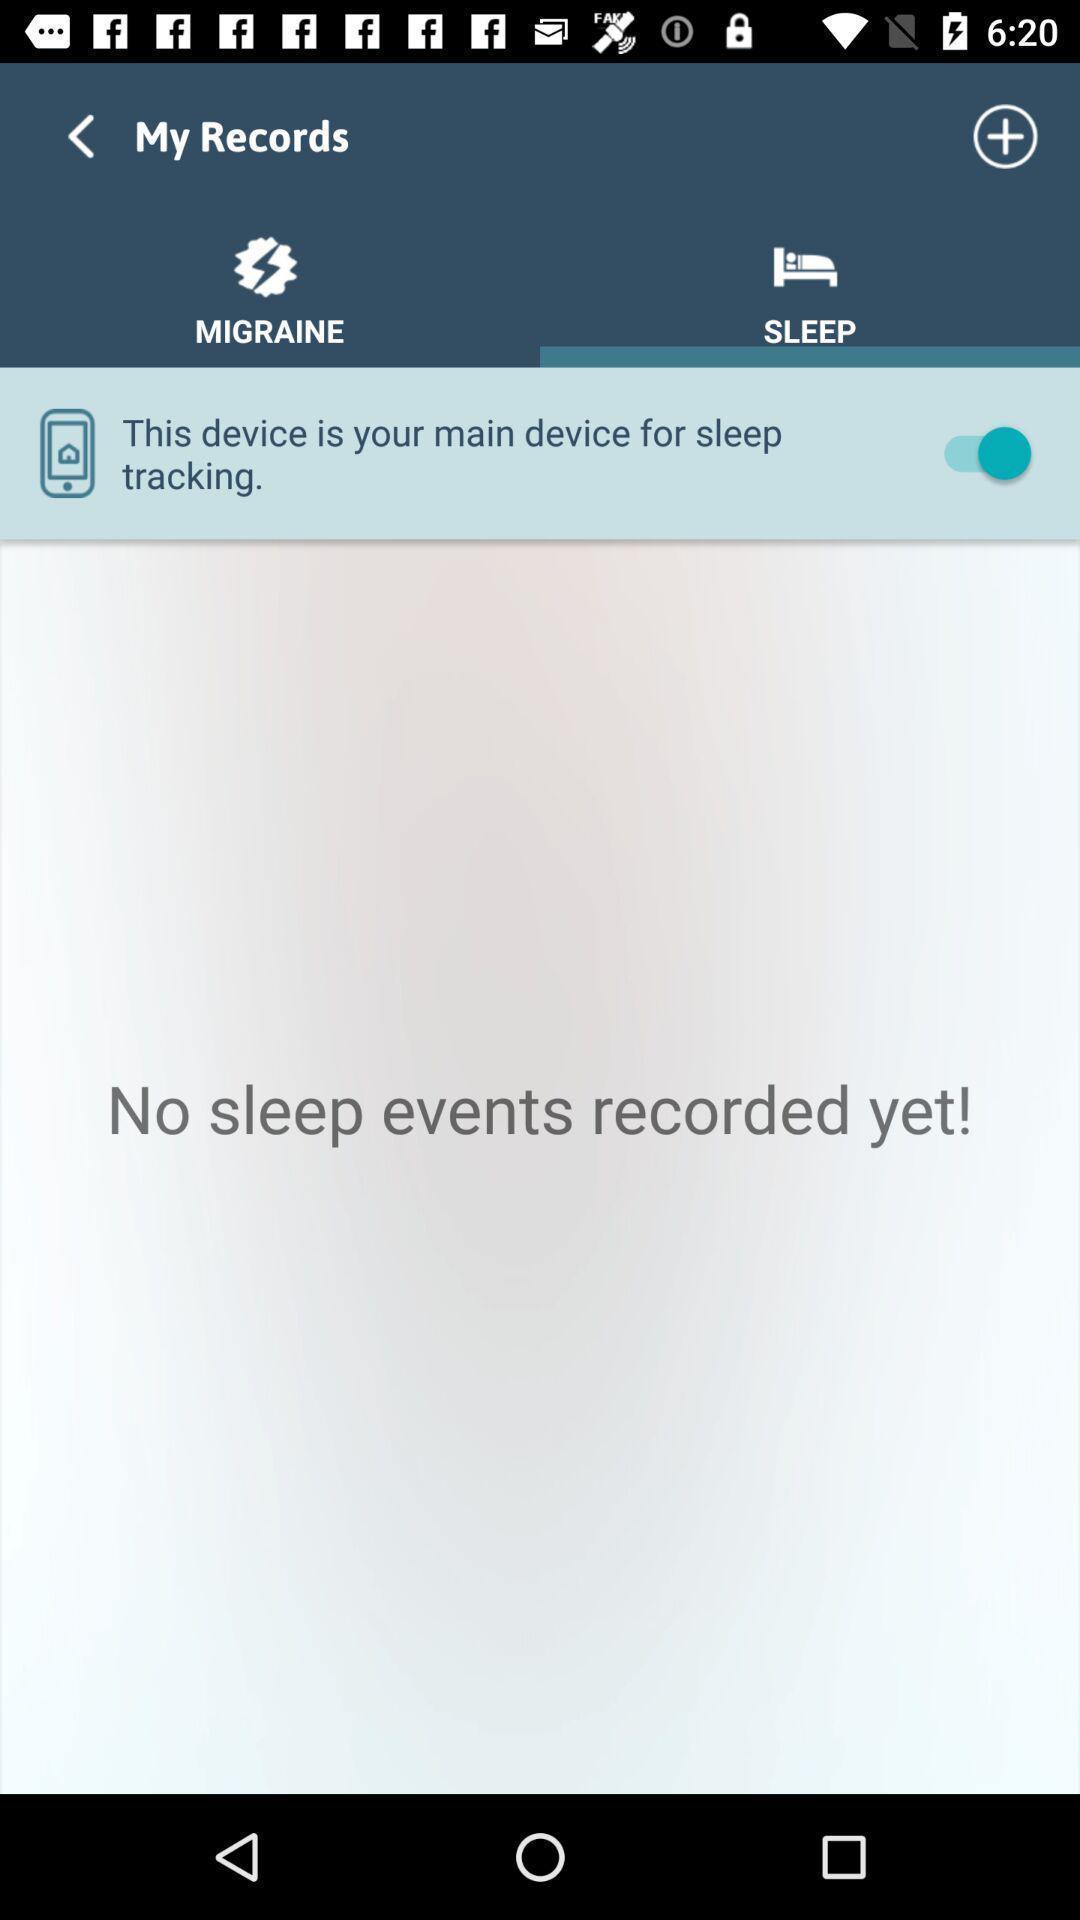Please provide a description for this image. Screen displaying the blank page in sleep tab. 